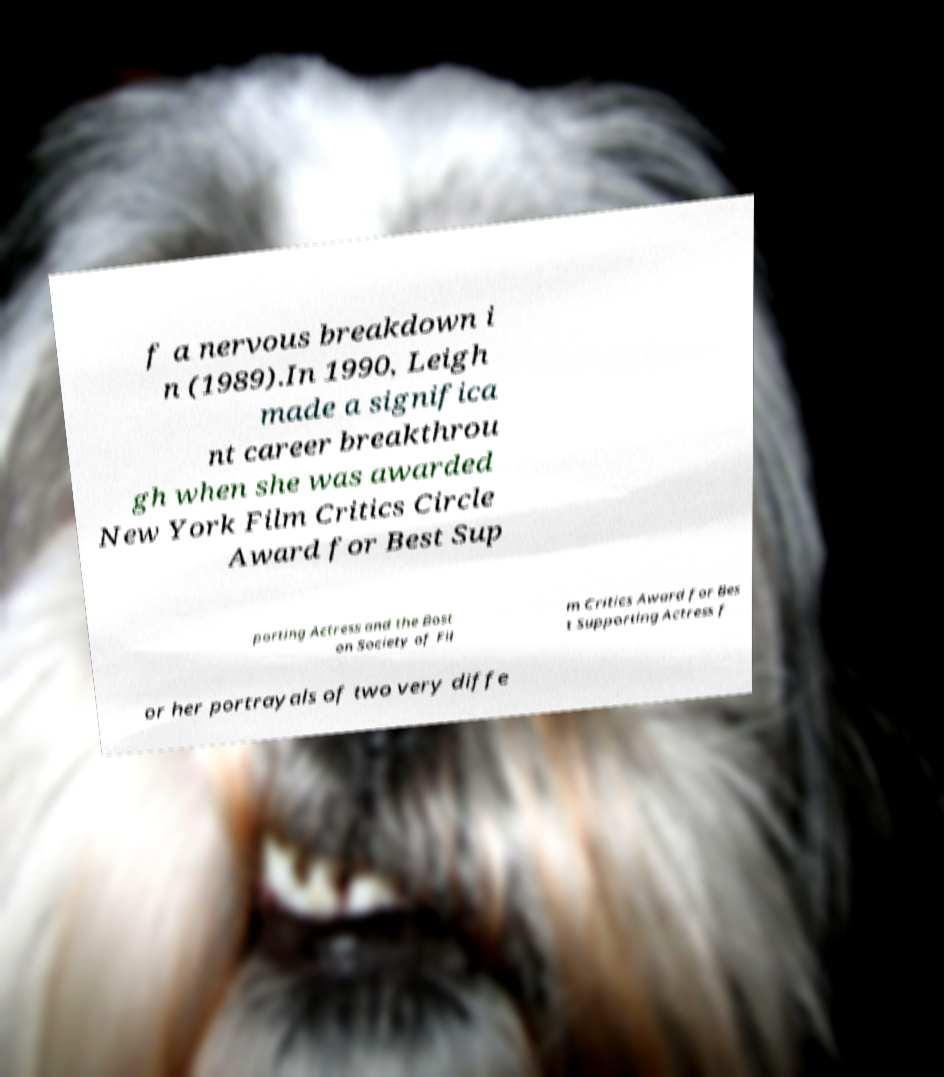Could you extract and type out the text from this image? f a nervous breakdown i n (1989).In 1990, Leigh made a significa nt career breakthrou gh when she was awarded New York Film Critics Circle Award for Best Sup porting Actress and the Bost on Society of Fil m Critics Award for Bes t Supporting Actress f or her portrayals of two very diffe 